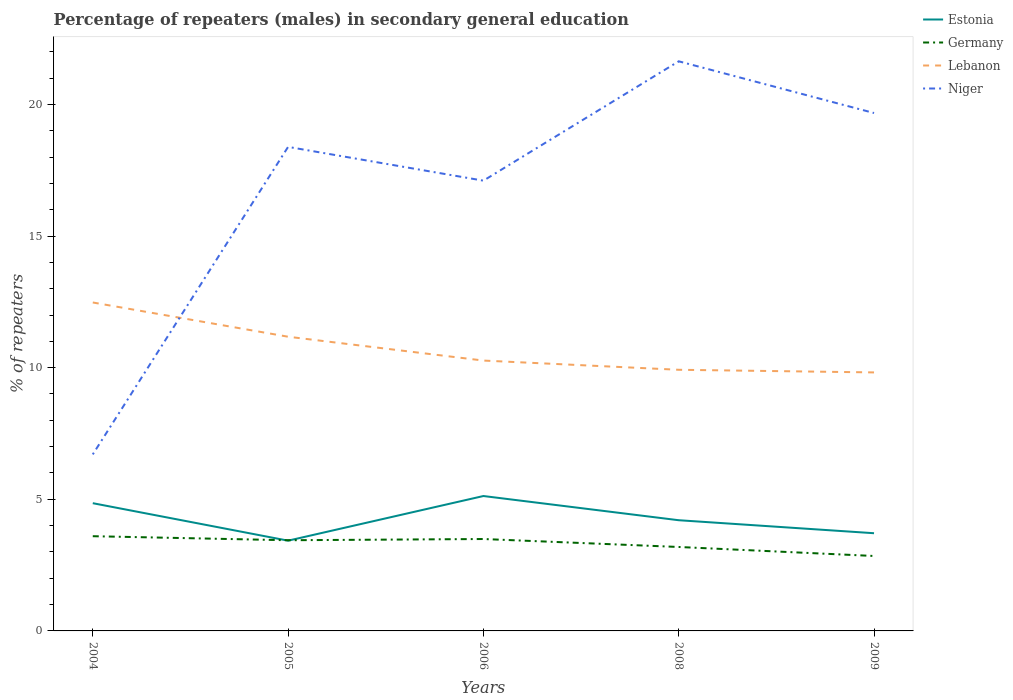Does the line corresponding to Niger intersect with the line corresponding to Germany?
Your answer should be compact. No. Across all years, what is the maximum percentage of male repeaters in Estonia?
Give a very brief answer. 3.43. In which year was the percentage of male repeaters in Estonia maximum?
Your answer should be very brief. 2005. What is the total percentage of male repeaters in Estonia in the graph?
Provide a short and direct response. -0.28. What is the difference between the highest and the second highest percentage of male repeaters in Niger?
Provide a succinct answer. 14.93. What is the difference between the highest and the lowest percentage of male repeaters in Estonia?
Your response must be concise. 2. How many lines are there?
Offer a very short reply. 4. How many years are there in the graph?
Provide a succinct answer. 5. What is the difference between two consecutive major ticks on the Y-axis?
Make the answer very short. 5. Are the values on the major ticks of Y-axis written in scientific E-notation?
Ensure brevity in your answer.  No. Does the graph contain any zero values?
Provide a short and direct response. No. Does the graph contain grids?
Provide a short and direct response. No. Where does the legend appear in the graph?
Make the answer very short. Top right. How many legend labels are there?
Offer a terse response. 4. What is the title of the graph?
Make the answer very short. Percentage of repeaters (males) in secondary general education. Does "Korea (Republic)" appear as one of the legend labels in the graph?
Give a very brief answer. No. What is the label or title of the Y-axis?
Offer a terse response. % of repeaters. What is the % of repeaters of Estonia in 2004?
Offer a terse response. 4.85. What is the % of repeaters in Germany in 2004?
Give a very brief answer. 3.6. What is the % of repeaters of Lebanon in 2004?
Offer a very short reply. 12.48. What is the % of repeaters of Niger in 2004?
Give a very brief answer. 6.71. What is the % of repeaters in Estonia in 2005?
Provide a short and direct response. 3.43. What is the % of repeaters of Germany in 2005?
Offer a terse response. 3.44. What is the % of repeaters in Lebanon in 2005?
Offer a terse response. 11.18. What is the % of repeaters of Niger in 2005?
Your answer should be very brief. 18.39. What is the % of repeaters in Estonia in 2006?
Offer a terse response. 5.12. What is the % of repeaters of Germany in 2006?
Give a very brief answer. 3.49. What is the % of repeaters of Lebanon in 2006?
Ensure brevity in your answer.  10.27. What is the % of repeaters in Niger in 2006?
Your answer should be very brief. 17.1. What is the % of repeaters of Estonia in 2008?
Provide a short and direct response. 4.2. What is the % of repeaters of Germany in 2008?
Ensure brevity in your answer.  3.19. What is the % of repeaters in Lebanon in 2008?
Offer a terse response. 9.92. What is the % of repeaters in Niger in 2008?
Provide a succinct answer. 21.64. What is the % of repeaters of Estonia in 2009?
Your answer should be very brief. 3.71. What is the % of repeaters in Germany in 2009?
Offer a terse response. 2.85. What is the % of repeaters of Lebanon in 2009?
Your response must be concise. 9.82. What is the % of repeaters in Niger in 2009?
Ensure brevity in your answer.  19.67. Across all years, what is the maximum % of repeaters of Estonia?
Offer a very short reply. 5.12. Across all years, what is the maximum % of repeaters in Germany?
Provide a short and direct response. 3.6. Across all years, what is the maximum % of repeaters of Lebanon?
Offer a terse response. 12.48. Across all years, what is the maximum % of repeaters of Niger?
Your response must be concise. 21.64. Across all years, what is the minimum % of repeaters of Estonia?
Provide a short and direct response. 3.43. Across all years, what is the minimum % of repeaters in Germany?
Give a very brief answer. 2.85. Across all years, what is the minimum % of repeaters in Lebanon?
Keep it short and to the point. 9.82. Across all years, what is the minimum % of repeaters in Niger?
Your answer should be very brief. 6.71. What is the total % of repeaters in Estonia in the graph?
Your answer should be compact. 21.32. What is the total % of repeaters in Germany in the graph?
Make the answer very short. 16.57. What is the total % of repeaters of Lebanon in the graph?
Offer a terse response. 53.66. What is the total % of repeaters of Niger in the graph?
Keep it short and to the point. 83.5. What is the difference between the % of repeaters in Estonia in 2004 and that in 2005?
Ensure brevity in your answer.  1.42. What is the difference between the % of repeaters in Germany in 2004 and that in 2005?
Your response must be concise. 0.15. What is the difference between the % of repeaters in Lebanon in 2004 and that in 2005?
Give a very brief answer. 1.3. What is the difference between the % of repeaters of Niger in 2004 and that in 2005?
Offer a terse response. -11.68. What is the difference between the % of repeaters of Estonia in 2004 and that in 2006?
Your response must be concise. -0.27. What is the difference between the % of repeaters of Germany in 2004 and that in 2006?
Offer a very short reply. 0.11. What is the difference between the % of repeaters of Lebanon in 2004 and that in 2006?
Make the answer very short. 2.21. What is the difference between the % of repeaters in Niger in 2004 and that in 2006?
Your response must be concise. -10.4. What is the difference between the % of repeaters of Estonia in 2004 and that in 2008?
Offer a terse response. 0.65. What is the difference between the % of repeaters of Germany in 2004 and that in 2008?
Your answer should be compact. 0.41. What is the difference between the % of repeaters of Lebanon in 2004 and that in 2008?
Your response must be concise. 2.56. What is the difference between the % of repeaters in Niger in 2004 and that in 2008?
Ensure brevity in your answer.  -14.93. What is the difference between the % of repeaters of Estonia in 2004 and that in 2009?
Make the answer very short. 1.14. What is the difference between the % of repeaters of Germany in 2004 and that in 2009?
Provide a succinct answer. 0.75. What is the difference between the % of repeaters of Lebanon in 2004 and that in 2009?
Your answer should be very brief. 2.66. What is the difference between the % of repeaters in Niger in 2004 and that in 2009?
Provide a short and direct response. -12.97. What is the difference between the % of repeaters of Estonia in 2005 and that in 2006?
Your answer should be compact. -1.7. What is the difference between the % of repeaters in Germany in 2005 and that in 2006?
Keep it short and to the point. -0.05. What is the difference between the % of repeaters in Lebanon in 2005 and that in 2006?
Provide a short and direct response. 0.91. What is the difference between the % of repeaters in Niger in 2005 and that in 2006?
Offer a terse response. 1.28. What is the difference between the % of repeaters of Estonia in 2005 and that in 2008?
Provide a succinct answer. -0.78. What is the difference between the % of repeaters in Germany in 2005 and that in 2008?
Your answer should be compact. 0.26. What is the difference between the % of repeaters in Lebanon in 2005 and that in 2008?
Provide a succinct answer. 1.26. What is the difference between the % of repeaters in Niger in 2005 and that in 2008?
Provide a succinct answer. -3.25. What is the difference between the % of repeaters in Estonia in 2005 and that in 2009?
Your response must be concise. -0.28. What is the difference between the % of repeaters of Germany in 2005 and that in 2009?
Provide a short and direct response. 0.6. What is the difference between the % of repeaters in Lebanon in 2005 and that in 2009?
Provide a short and direct response. 1.36. What is the difference between the % of repeaters of Niger in 2005 and that in 2009?
Your answer should be very brief. -1.29. What is the difference between the % of repeaters in Estonia in 2006 and that in 2008?
Provide a short and direct response. 0.92. What is the difference between the % of repeaters of Germany in 2006 and that in 2008?
Provide a short and direct response. 0.3. What is the difference between the % of repeaters of Lebanon in 2006 and that in 2008?
Offer a terse response. 0.35. What is the difference between the % of repeaters in Niger in 2006 and that in 2008?
Make the answer very short. -4.53. What is the difference between the % of repeaters in Estonia in 2006 and that in 2009?
Offer a terse response. 1.41. What is the difference between the % of repeaters in Germany in 2006 and that in 2009?
Provide a succinct answer. 0.64. What is the difference between the % of repeaters in Lebanon in 2006 and that in 2009?
Give a very brief answer. 0.45. What is the difference between the % of repeaters in Niger in 2006 and that in 2009?
Provide a succinct answer. -2.57. What is the difference between the % of repeaters in Estonia in 2008 and that in 2009?
Give a very brief answer. 0.49. What is the difference between the % of repeaters in Germany in 2008 and that in 2009?
Give a very brief answer. 0.34. What is the difference between the % of repeaters in Lebanon in 2008 and that in 2009?
Your response must be concise. 0.1. What is the difference between the % of repeaters of Niger in 2008 and that in 2009?
Offer a terse response. 1.96. What is the difference between the % of repeaters of Estonia in 2004 and the % of repeaters of Germany in 2005?
Your response must be concise. 1.41. What is the difference between the % of repeaters in Estonia in 2004 and the % of repeaters in Lebanon in 2005?
Ensure brevity in your answer.  -6.32. What is the difference between the % of repeaters in Estonia in 2004 and the % of repeaters in Niger in 2005?
Offer a very short reply. -13.53. What is the difference between the % of repeaters in Germany in 2004 and the % of repeaters in Lebanon in 2005?
Provide a succinct answer. -7.58. What is the difference between the % of repeaters in Germany in 2004 and the % of repeaters in Niger in 2005?
Provide a short and direct response. -14.79. What is the difference between the % of repeaters of Lebanon in 2004 and the % of repeaters of Niger in 2005?
Provide a short and direct response. -5.91. What is the difference between the % of repeaters of Estonia in 2004 and the % of repeaters of Germany in 2006?
Your answer should be very brief. 1.36. What is the difference between the % of repeaters of Estonia in 2004 and the % of repeaters of Lebanon in 2006?
Provide a short and direct response. -5.42. What is the difference between the % of repeaters in Estonia in 2004 and the % of repeaters in Niger in 2006?
Offer a terse response. -12.25. What is the difference between the % of repeaters in Germany in 2004 and the % of repeaters in Lebanon in 2006?
Keep it short and to the point. -6.67. What is the difference between the % of repeaters in Germany in 2004 and the % of repeaters in Niger in 2006?
Give a very brief answer. -13.51. What is the difference between the % of repeaters of Lebanon in 2004 and the % of repeaters of Niger in 2006?
Provide a succinct answer. -4.63. What is the difference between the % of repeaters in Estonia in 2004 and the % of repeaters in Germany in 2008?
Provide a succinct answer. 1.66. What is the difference between the % of repeaters of Estonia in 2004 and the % of repeaters of Lebanon in 2008?
Offer a very short reply. -5.07. What is the difference between the % of repeaters in Estonia in 2004 and the % of repeaters in Niger in 2008?
Make the answer very short. -16.79. What is the difference between the % of repeaters of Germany in 2004 and the % of repeaters of Lebanon in 2008?
Ensure brevity in your answer.  -6.32. What is the difference between the % of repeaters of Germany in 2004 and the % of repeaters of Niger in 2008?
Your answer should be very brief. -18.04. What is the difference between the % of repeaters in Lebanon in 2004 and the % of repeaters in Niger in 2008?
Your response must be concise. -9.16. What is the difference between the % of repeaters in Estonia in 2004 and the % of repeaters in Germany in 2009?
Your answer should be compact. 2.01. What is the difference between the % of repeaters of Estonia in 2004 and the % of repeaters of Lebanon in 2009?
Provide a short and direct response. -4.97. What is the difference between the % of repeaters of Estonia in 2004 and the % of repeaters of Niger in 2009?
Offer a very short reply. -14.82. What is the difference between the % of repeaters of Germany in 2004 and the % of repeaters of Lebanon in 2009?
Your answer should be compact. -6.22. What is the difference between the % of repeaters in Germany in 2004 and the % of repeaters in Niger in 2009?
Keep it short and to the point. -16.07. What is the difference between the % of repeaters of Lebanon in 2004 and the % of repeaters of Niger in 2009?
Ensure brevity in your answer.  -7.2. What is the difference between the % of repeaters of Estonia in 2005 and the % of repeaters of Germany in 2006?
Offer a very short reply. -0.06. What is the difference between the % of repeaters in Estonia in 2005 and the % of repeaters in Lebanon in 2006?
Give a very brief answer. -6.84. What is the difference between the % of repeaters in Estonia in 2005 and the % of repeaters in Niger in 2006?
Keep it short and to the point. -13.68. What is the difference between the % of repeaters of Germany in 2005 and the % of repeaters of Lebanon in 2006?
Provide a succinct answer. -6.83. What is the difference between the % of repeaters in Germany in 2005 and the % of repeaters in Niger in 2006?
Your answer should be very brief. -13.66. What is the difference between the % of repeaters in Lebanon in 2005 and the % of repeaters in Niger in 2006?
Your response must be concise. -5.93. What is the difference between the % of repeaters of Estonia in 2005 and the % of repeaters of Germany in 2008?
Make the answer very short. 0.24. What is the difference between the % of repeaters in Estonia in 2005 and the % of repeaters in Lebanon in 2008?
Your response must be concise. -6.49. What is the difference between the % of repeaters of Estonia in 2005 and the % of repeaters of Niger in 2008?
Your response must be concise. -18.21. What is the difference between the % of repeaters of Germany in 2005 and the % of repeaters of Lebanon in 2008?
Give a very brief answer. -6.47. What is the difference between the % of repeaters in Germany in 2005 and the % of repeaters in Niger in 2008?
Provide a succinct answer. -18.19. What is the difference between the % of repeaters in Lebanon in 2005 and the % of repeaters in Niger in 2008?
Provide a short and direct response. -10.46. What is the difference between the % of repeaters of Estonia in 2005 and the % of repeaters of Germany in 2009?
Offer a very short reply. 0.58. What is the difference between the % of repeaters of Estonia in 2005 and the % of repeaters of Lebanon in 2009?
Keep it short and to the point. -6.39. What is the difference between the % of repeaters in Estonia in 2005 and the % of repeaters in Niger in 2009?
Your answer should be very brief. -16.24. What is the difference between the % of repeaters of Germany in 2005 and the % of repeaters of Lebanon in 2009?
Ensure brevity in your answer.  -6.37. What is the difference between the % of repeaters in Germany in 2005 and the % of repeaters in Niger in 2009?
Give a very brief answer. -16.23. What is the difference between the % of repeaters of Lebanon in 2005 and the % of repeaters of Niger in 2009?
Make the answer very short. -8.5. What is the difference between the % of repeaters of Estonia in 2006 and the % of repeaters of Germany in 2008?
Keep it short and to the point. 1.94. What is the difference between the % of repeaters in Estonia in 2006 and the % of repeaters in Lebanon in 2008?
Your answer should be very brief. -4.8. What is the difference between the % of repeaters in Estonia in 2006 and the % of repeaters in Niger in 2008?
Make the answer very short. -16.51. What is the difference between the % of repeaters in Germany in 2006 and the % of repeaters in Lebanon in 2008?
Your response must be concise. -6.43. What is the difference between the % of repeaters of Germany in 2006 and the % of repeaters of Niger in 2008?
Offer a very short reply. -18.15. What is the difference between the % of repeaters in Lebanon in 2006 and the % of repeaters in Niger in 2008?
Provide a short and direct response. -11.37. What is the difference between the % of repeaters in Estonia in 2006 and the % of repeaters in Germany in 2009?
Your answer should be very brief. 2.28. What is the difference between the % of repeaters in Estonia in 2006 and the % of repeaters in Lebanon in 2009?
Provide a succinct answer. -4.7. What is the difference between the % of repeaters of Estonia in 2006 and the % of repeaters of Niger in 2009?
Make the answer very short. -14.55. What is the difference between the % of repeaters in Germany in 2006 and the % of repeaters in Lebanon in 2009?
Make the answer very short. -6.33. What is the difference between the % of repeaters in Germany in 2006 and the % of repeaters in Niger in 2009?
Give a very brief answer. -16.18. What is the difference between the % of repeaters in Lebanon in 2006 and the % of repeaters in Niger in 2009?
Keep it short and to the point. -9.4. What is the difference between the % of repeaters of Estonia in 2008 and the % of repeaters of Germany in 2009?
Provide a short and direct response. 1.36. What is the difference between the % of repeaters of Estonia in 2008 and the % of repeaters of Lebanon in 2009?
Provide a short and direct response. -5.61. What is the difference between the % of repeaters in Estonia in 2008 and the % of repeaters in Niger in 2009?
Your answer should be compact. -15.47. What is the difference between the % of repeaters of Germany in 2008 and the % of repeaters of Lebanon in 2009?
Keep it short and to the point. -6.63. What is the difference between the % of repeaters in Germany in 2008 and the % of repeaters in Niger in 2009?
Your answer should be compact. -16.48. What is the difference between the % of repeaters in Lebanon in 2008 and the % of repeaters in Niger in 2009?
Offer a terse response. -9.75. What is the average % of repeaters of Estonia per year?
Offer a very short reply. 4.26. What is the average % of repeaters in Germany per year?
Your answer should be very brief. 3.31. What is the average % of repeaters in Lebanon per year?
Ensure brevity in your answer.  10.73. What is the average % of repeaters in Niger per year?
Offer a terse response. 16.7. In the year 2004, what is the difference between the % of repeaters of Estonia and % of repeaters of Germany?
Give a very brief answer. 1.25. In the year 2004, what is the difference between the % of repeaters in Estonia and % of repeaters in Lebanon?
Ensure brevity in your answer.  -7.62. In the year 2004, what is the difference between the % of repeaters of Estonia and % of repeaters of Niger?
Your answer should be very brief. -1.85. In the year 2004, what is the difference between the % of repeaters in Germany and % of repeaters in Lebanon?
Your answer should be compact. -8.88. In the year 2004, what is the difference between the % of repeaters of Germany and % of repeaters of Niger?
Offer a very short reply. -3.11. In the year 2004, what is the difference between the % of repeaters of Lebanon and % of repeaters of Niger?
Your answer should be compact. 5.77. In the year 2005, what is the difference between the % of repeaters in Estonia and % of repeaters in Germany?
Offer a terse response. -0.02. In the year 2005, what is the difference between the % of repeaters in Estonia and % of repeaters in Lebanon?
Ensure brevity in your answer.  -7.75. In the year 2005, what is the difference between the % of repeaters in Estonia and % of repeaters in Niger?
Ensure brevity in your answer.  -14.96. In the year 2005, what is the difference between the % of repeaters in Germany and % of repeaters in Lebanon?
Provide a short and direct response. -7.73. In the year 2005, what is the difference between the % of repeaters in Germany and % of repeaters in Niger?
Your answer should be compact. -14.94. In the year 2005, what is the difference between the % of repeaters in Lebanon and % of repeaters in Niger?
Your answer should be very brief. -7.21. In the year 2006, what is the difference between the % of repeaters in Estonia and % of repeaters in Germany?
Provide a short and direct response. 1.63. In the year 2006, what is the difference between the % of repeaters of Estonia and % of repeaters of Lebanon?
Ensure brevity in your answer.  -5.15. In the year 2006, what is the difference between the % of repeaters in Estonia and % of repeaters in Niger?
Provide a succinct answer. -11.98. In the year 2006, what is the difference between the % of repeaters of Germany and % of repeaters of Lebanon?
Provide a short and direct response. -6.78. In the year 2006, what is the difference between the % of repeaters of Germany and % of repeaters of Niger?
Provide a succinct answer. -13.61. In the year 2006, what is the difference between the % of repeaters in Lebanon and % of repeaters in Niger?
Offer a terse response. -6.83. In the year 2008, what is the difference between the % of repeaters in Estonia and % of repeaters in Germany?
Provide a succinct answer. 1.02. In the year 2008, what is the difference between the % of repeaters in Estonia and % of repeaters in Lebanon?
Give a very brief answer. -5.71. In the year 2008, what is the difference between the % of repeaters in Estonia and % of repeaters in Niger?
Keep it short and to the point. -17.43. In the year 2008, what is the difference between the % of repeaters in Germany and % of repeaters in Lebanon?
Your answer should be very brief. -6.73. In the year 2008, what is the difference between the % of repeaters of Germany and % of repeaters of Niger?
Offer a very short reply. -18.45. In the year 2008, what is the difference between the % of repeaters in Lebanon and % of repeaters in Niger?
Your answer should be very brief. -11.72. In the year 2009, what is the difference between the % of repeaters of Estonia and % of repeaters of Germany?
Your answer should be compact. 0.86. In the year 2009, what is the difference between the % of repeaters in Estonia and % of repeaters in Lebanon?
Keep it short and to the point. -6.11. In the year 2009, what is the difference between the % of repeaters in Estonia and % of repeaters in Niger?
Your answer should be very brief. -15.96. In the year 2009, what is the difference between the % of repeaters of Germany and % of repeaters of Lebanon?
Give a very brief answer. -6.97. In the year 2009, what is the difference between the % of repeaters in Germany and % of repeaters in Niger?
Give a very brief answer. -16.83. In the year 2009, what is the difference between the % of repeaters in Lebanon and % of repeaters in Niger?
Give a very brief answer. -9.85. What is the ratio of the % of repeaters of Estonia in 2004 to that in 2005?
Keep it short and to the point. 1.42. What is the ratio of the % of repeaters of Germany in 2004 to that in 2005?
Keep it short and to the point. 1.04. What is the ratio of the % of repeaters of Lebanon in 2004 to that in 2005?
Provide a succinct answer. 1.12. What is the ratio of the % of repeaters in Niger in 2004 to that in 2005?
Keep it short and to the point. 0.36. What is the ratio of the % of repeaters in Estonia in 2004 to that in 2006?
Give a very brief answer. 0.95. What is the ratio of the % of repeaters of Germany in 2004 to that in 2006?
Offer a terse response. 1.03. What is the ratio of the % of repeaters of Lebanon in 2004 to that in 2006?
Give a very brief answer. 1.21. What is the ratio of the % of repeaters of Niger in 2004 to that in 2006?
Your response must be concise. 0.39. What is the ratio of the % of repeaters of Estonia in 2004 to that in 2008?
Keep it short and to the point. 1.15. What is the ratio of the % of repeaters in Germany in 2004 to that in 2008?
Your answer should be very brief. 1.13. What is the ratio of the % of repeaters in Lebanon in 2004 to that in 2008?
Your response must be concise. 1.26. What is the ratio of the % of repeaters of Niger in 2004 to that in 2008?
Keep it short and to the point. 0.31. What is the ratio of the % of repeaters of Estonia in 2004 to that in 2009?
Your response must be concise. 1.31. What is the ratio of the % of repeaters in Germany in 2004 to that in 2009?
Your answer should be very brief. 1.26. What is the ratio of the % of repeaters in Lebanon in 2004 to that in 2009?
Your answer should be very brief. 1.27. What is the ratio of the % of repeaters in Niger in 2004 to that in 2009?
Provide a short and direct response. 0.34. What is the ratio of the % of repeaters in Estonia in 2005 to that in 2006?
Give a very brief answer. 0.67. What is the ratio of the % of repeaters in Germany in 2005 to that in 2006?
Your answer should be very brief. 0.99. What is the ratio of the % of repeaters of Lebanon in 2005 to that in 2006?
Ensure brevity in your answer.  1.09. What is the ratio of the % of repeaters of Niger in 2005 to that in 2006?
Offer a very short reply. 1.07. What is the ratio of the % of repeaters of Estonia in 2005 to that in 2008?
Provide a short and direct response. 0.82. What is the ratio of the % of repeaters in Germany in 2005 to that in 2008?
Your response must be concise. 1.08. What is the ratio of the % of repeaters in Lebanon in 2005 to that in 2008?
Provide a short and direct response. 1.13. What is the ratio of the % of repeaters in Niger in 2005 to that in 2008?
Offer a very short reply. 0.85. What is the ratio of the % of repeaters of Estonia in 2005 to that in 2009?
Give a very brief answer. 0.92. What is the ratio of the % of repeaters in Germany in 2005 to that in 2009?
Keep it short and to the point. 1.21. What is the ratio of the % of repeaters in Lebanon in 2005 to that in 2009?
Offer a very short reply. 1.14. What is the ratio of the % of repeaters of Niger in 2005 to that in 2009?
Offer a terse response. 0.93. What is the ratio of the % of repeaters in Estonia in 2006 to that in 2008?
Your answer should be compact. 1.22. What is the ratio of the % of repeaters in Germany in 2006 to that in 2008?
Make the answer very short. 1.09. What is the ratio of the % of repeaters of Lebanon in 2006 to that in 2008?
Offer a terse response. 1.04. What is the ratio of the % of repeaters in Niger in 2006 to that in 2008?
Your response must be concise. 0.79. What is the ratio of the % of repeaters in Estonia in 2006 to that in 2009?
Provide a succinct answer. 1.38. What is the ratio of the % of repeaters of Germany in 2006 to that in 2009?
Ensure brevity in your answer.  1.23. What is the ratio of the % of repeaters in Lebanon in 2006 to that in 2009?
Your answer should be compact. 1.05. What is the ratio of the % of repeaters in Niger in 2006 to that in 2009?
Make the answer very short. 0.87. What is the ratio of the % of repeaters of Estonia in 2008 to that in 2009?
Provide a succinct answer. 1.13. What is the ratio of the % of repeaters of Germany in 2008 to that in 2009?
Offer a very short reply. 1.12. What is the ratio of the % of repeaters of Lebanon in 2008 to that in 2009?
Give a very brief answer. 1.01. What is the ratio of the % of repeaters of Niger in 2008 to that in 2009?
Provide a succinct answer. 1.1. What is the difference between the highest and the second highest % of repeaters in Estonia?
Give a very brief answer. 0.27. What is the difference between the highest and the second highest % of repeaters in Germany?
Your answer should be very brief. 0.11. What is the difference between the highest and the second highest % of repeaters of Lebanon?
Ensure brevity in your answer.  1.3. What is the difference between the highest and the second highest % of repeaters of Niger?
Your answer should be very brief. 1.96. What is the difference between the highest and the lowest % of repeaters of Estonia?
Offer a very short reply. 1.7. What is the difference between the highest and the lowest % of repeaters in Germany?
Ensure brevity in your answer.  0.75. What is the difference between the highest and the lowest % of repeaters of Lebanon?
Keep it short and to the point. 2.66. What is the difference between the highest and the lowest % of repeaters in Niger?
Keep it short and to the point. 14.93. 